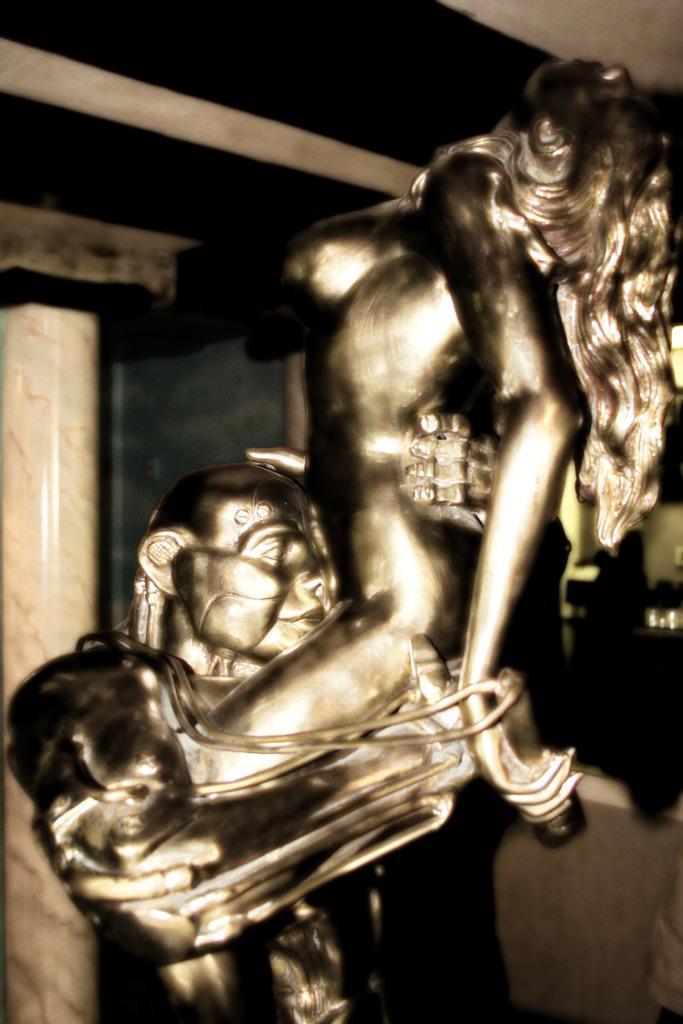In one or two sentences, can you explain what this image depicts? In this picture there is a sculpture of a person holding the other person. At the back there is a pillar and there is a wall. 